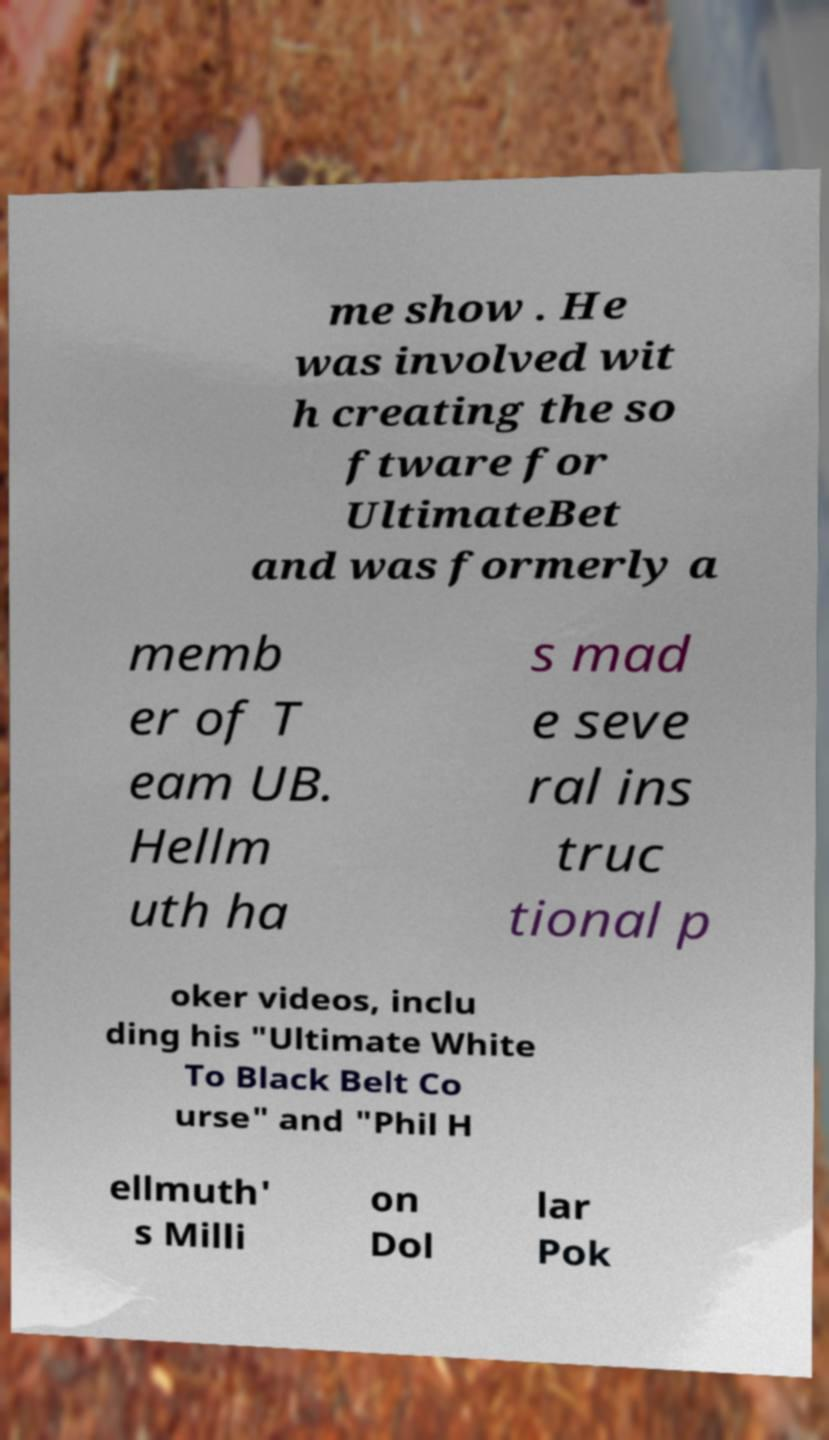Please read and relay the text visible in this image. What does it say? me show . He was involved wit h creating the so ftware for UltimateBet and was formerly a memb er of T eam UB. Hellm uth ha s mad e seve ral ins truc tional p oker videos, inclu ding his "Ultimate White To Black Belt Co urse" and "Phil H ellmuth' s Milli on Dol lar Pok 